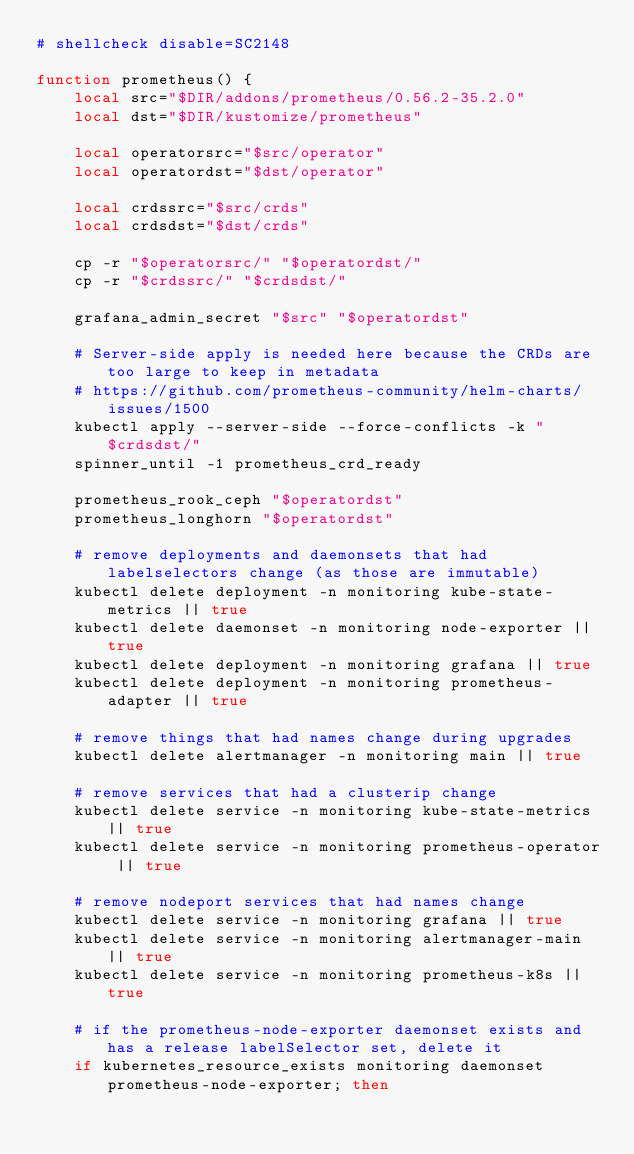<code> <loc_0><loc_0><loc_500><loc_500><_Bash_># shellcheck disable=SC2148

function prometheus() {
    local src="$DIR/addons/prometheus/0.56.2-35.2.0"
    local dst="$DIR/kustomize/prometheus"

    local operatorsrc="$src/operator"
    local operatordst="$dst/operator"

    local crdssrc="$src/crds"
    local crdsdst="$dst/crds"

    cp -r "$operatorsrc/" "$operatordst/"
    cp -r "$crdssrc/" "$crdsdst/"

    grafana_admin_secret "$src" "$operatordst"

    # Server-side apply is needed here because the CRDs are too large to keep in metadata
    # https://github.com/prometheus-community/helm-charts/issues/1500
    kubectl apply --server-side --force-conflicts -k "$crdsdst/"
    spinner_until -1 prometheus_crd_ready

    prometheus_rook_ceph "$operatordst"
    prometheus_longhorn "$operatordst"

    # remove deployments and daemonsets that had labelselectors change (as those are immutable)
    kubectl delete deployment -n monitoring kube-state-metrics || true
    kubectl delete daemonset -n monitoring node-exporter || true
    kubectl delete deployment -n monitoring grafana || true
    kubectl delete deployment -n monitoring prometheus-adapter || true

    # remove things that had names change during upgrades
    kubectl delete alertmanager -n monitoring main || true

    # remove services that had a clusterip change
    kubectl delete service -n monitoring kube-state-metrics || true
    kubectl delete service -n monitoring prometheus-operator || true

    # remove nodeport services that had names change
    kubectl delete service -n monitoring grafana || true
    kubectl delete service -n monitoring alertmanager-main || true
    kubectl delete service -n monitoring prometheus-k8s || true

    # if the prometheus-node-exporter daemonset exists and has a release labelSelector set, delete it
    if kubernetes_resource_exists monitoring daemonset prometheus-node-exporter; then</code> 